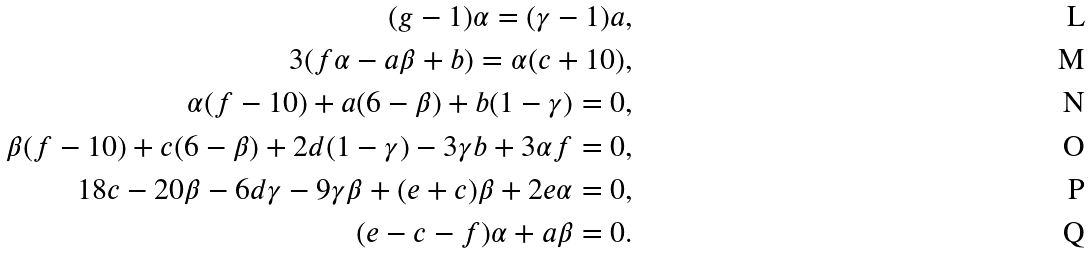<formula> <loc_0><loc_0><loc_500><loc_500>( g - 1 ) \alpha = ( \gamma - 1 ) a , \\ 3 ( f \alpha - a \beta + b ) = \alpha ( c + 1 0 ) , \\ \alpha ( f - 1 0 ) + a ( 6 - \beta ) + b ( 1 - \gamma ) = 0 , \\ \beta ( f - 1 0 ) + c ( 6 - \beta ) + 2 d ( 1 - \gamma ) - 3 \gamma b + 3 \alpha f = 0 , \\ 1 8 c - 2 0 \beta - 6 d \gamma - 9 \gamma \beta + ( e + c ) \beta + 2 e \alpha = 0 , \\ ( e - c - f ) \alpha + a \beta = 0 .</formula> 